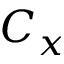Convert formula to latex. <formula><loc_0><loc_0><loc_500><loc_500>C _ { x }</formula> 